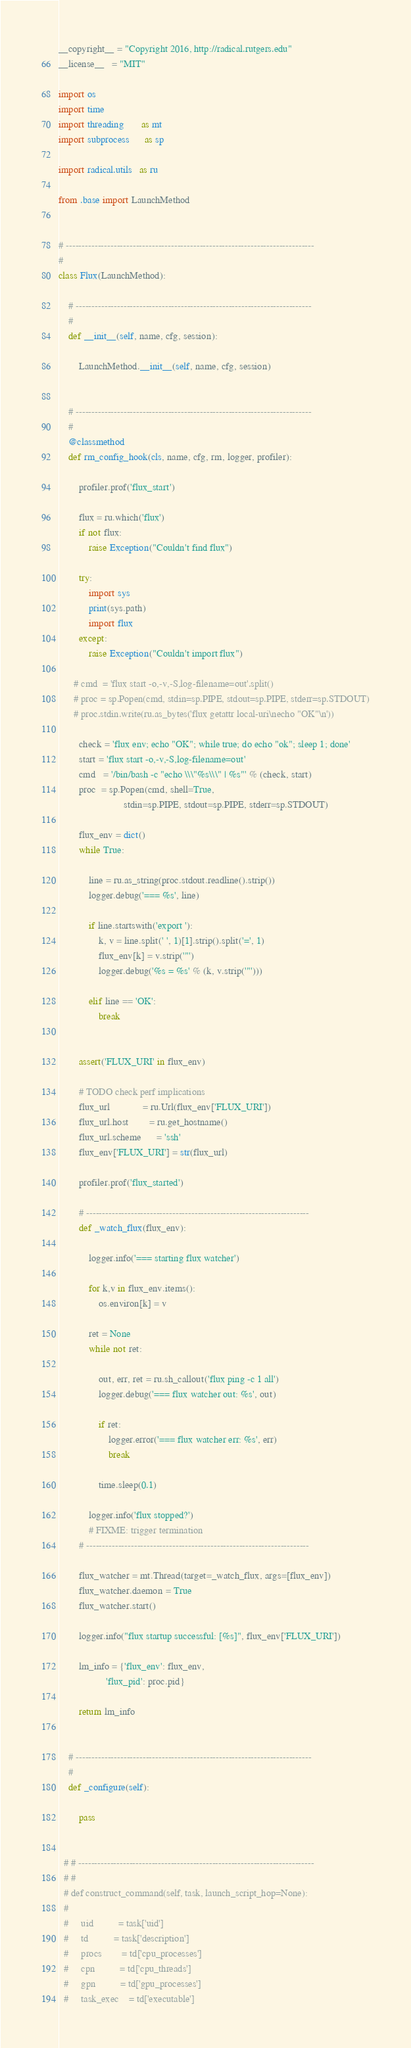<code> <loc_0><loc_0><loc_500><loc_500><_Python_>
__copyright__ = "Copyright 2016, http://radical.rutgers.edu"
__license__   = "MIT"

import os
import time
import threading       as mt
import subprocess      as sp

import radical.utils   as ru

from .base import LaunchMethod


# ------------------------------------------------------------------------------
#
class Flux(LaunchMethod):

    # --------------------------------------------------------------------------
    #
    def __init__(self, name, cfg, session):

        LaunchMethod.__init__(self, name, cfg, session)


    # --------------------------------------------------------------------------
    #
    @classmethod
    def rm_config_hook(cls, name, cfg, rm, logger, profiler):

        profiler.prof('flux_start')

        flux = ru.which('flux')
        if not flux:
            raise Exception("Couldn't find flux")

        try:
            import sys
            print(sys.path)
            import flux
        except:
            raise Exception("Couldn't import flux")

      # cmd  = 'flux start -o,-v,-S,log-filename=out'.split()
      # proc = sp.Popen(cmd, stdin=sp.PIPE, stdout=sp.PIPE, stderr=sp.STDOUT)
      # proc.stdin.write(ru.as_bytes('flux getattr local-uri\necho "OK"\n'))

        check = 'flux env; echo "OK"; while true; do echo "ok"; sleep 1; done'
        start = 'flux start -o,-v,-S,log-filename=out'
        cmd   = '/bin/bash -c "echo \\\"%s\\\" | %s"' % (check, start)
        proc  = sp.Popen(cmd, shell=True,
                          stdin=sp.PIPE, stdout=sp.PIPE, stderr=sp.STDOUT)

        flux_env = dict()
        while True:

            line = ru.as_string(proc.stdout.readline().strip())
            logger.debug('=== %s', line)

            if line.startswith('export '):
                k, v = line.split(' ', 1)[1].strip().split('=', 1)
                flux_env[k] = v.strip('"')
                logger.debug('%s = %s' % (k, v.strip('"')))

            elif line == 'OK':
                break


        assert('FLUX_URI' in flux_env)

        # TODO check perf implications
        flux_url             = ru.Url(flux_env['FLUX_URI'])
        flux_url.host        = ru.get_hostname()
        flux_url.scheme      = 'ssh'
        flux_env['FLUX_URI'] = str(flux_url)

        profiler.prof('flux_started')

        # ----------------------------------------------------------------------
        def _watch_flux(flux_env):

            logger.info('=== starting flux watcher')

            for k,v in flux_env.items():
                os.environ[k] = v

            ret = None
            while not ret:

                out, err, ret = ru.sh_callout('flux ping -c 1 all')
                logger.debug('=== flux watcher out: %s', out)

                if ret:
                    logger.error('=== flux watcher err: %s', err)
                    break

                time.sleep(0.1)

            logger.info('flux stopped?')
            # FIXME: trigger termination
        # ----------------------------------------------------------------------

        flux_watcher = mt.Thread(target=_watch_flux, args=[flux_env])
        flux_watcher.daemon = True
        flux_watcher.start()

        logger.info("flux startup successful: [%s]", flux_env['FLUX_URI'])

        lm_info = {'flux_env': flux_env,
                   'flux_pid': proc.pid}

        return lm_info


    # --------------------------------------------------------------------------
    #
    def _configure(self):

        pass


  # # --------------------------------------------------------------------------
  # #
  # def construct_command(self, task, launch_script_hop=None):
  #
  #     uid          = task['uid']
  #     td          = task['description']
  #     procs        = td['cpu_processes']
  #     cpn          = td['cpu_threads']
  #     gpn          = td['gpu_processes']
  #     task_exec    = td['executable']</code> 